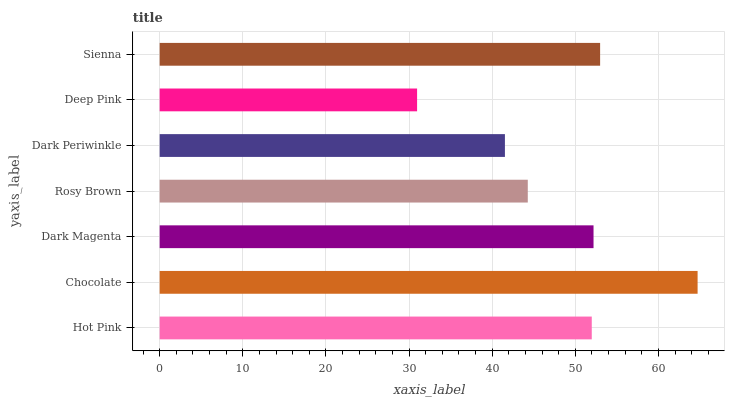Is Deep Pink the minimum?
Answer yes or no. Yes. Is Chocolate the maximum?
Answer yes or no. Yes. Is Dark Magenta the minimum?
Answer yes or no. No. Is Dark Magenta the maximum?
Answer yes or no. No. Is Chocolate greater than Dark Magenta?
Answer yes or no. Yes. Is Dark Magenta less than Chocolate?
Answer yes or no. Yes. Is Dark Magenta greater than Chocolate?
Answer yes or no. No. Is Chocolate less than Dark Magenta?
Answer yes or no. No. Is Hot Pink the high median?
Answer yes or no. Yes. Is Hot Pink the low median?
Answer yes or no. Yes. Is Sienna the high median?
Answer yes or no. No. Is Chocolate the low median?
Answer yes or no. No. 